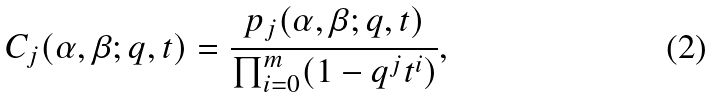<formula> <loc_0><loc_0><loc_500><loc_500>C _ { j } ( \alpha , \beta ; q , t ) = \frac { p _ { j } ( \alpha , \beta ; q , t ) } { \prod _ { i = 0 } ^ { m } ( 1 - q ^ { j } t ^ { i } ) } ,</formula> 